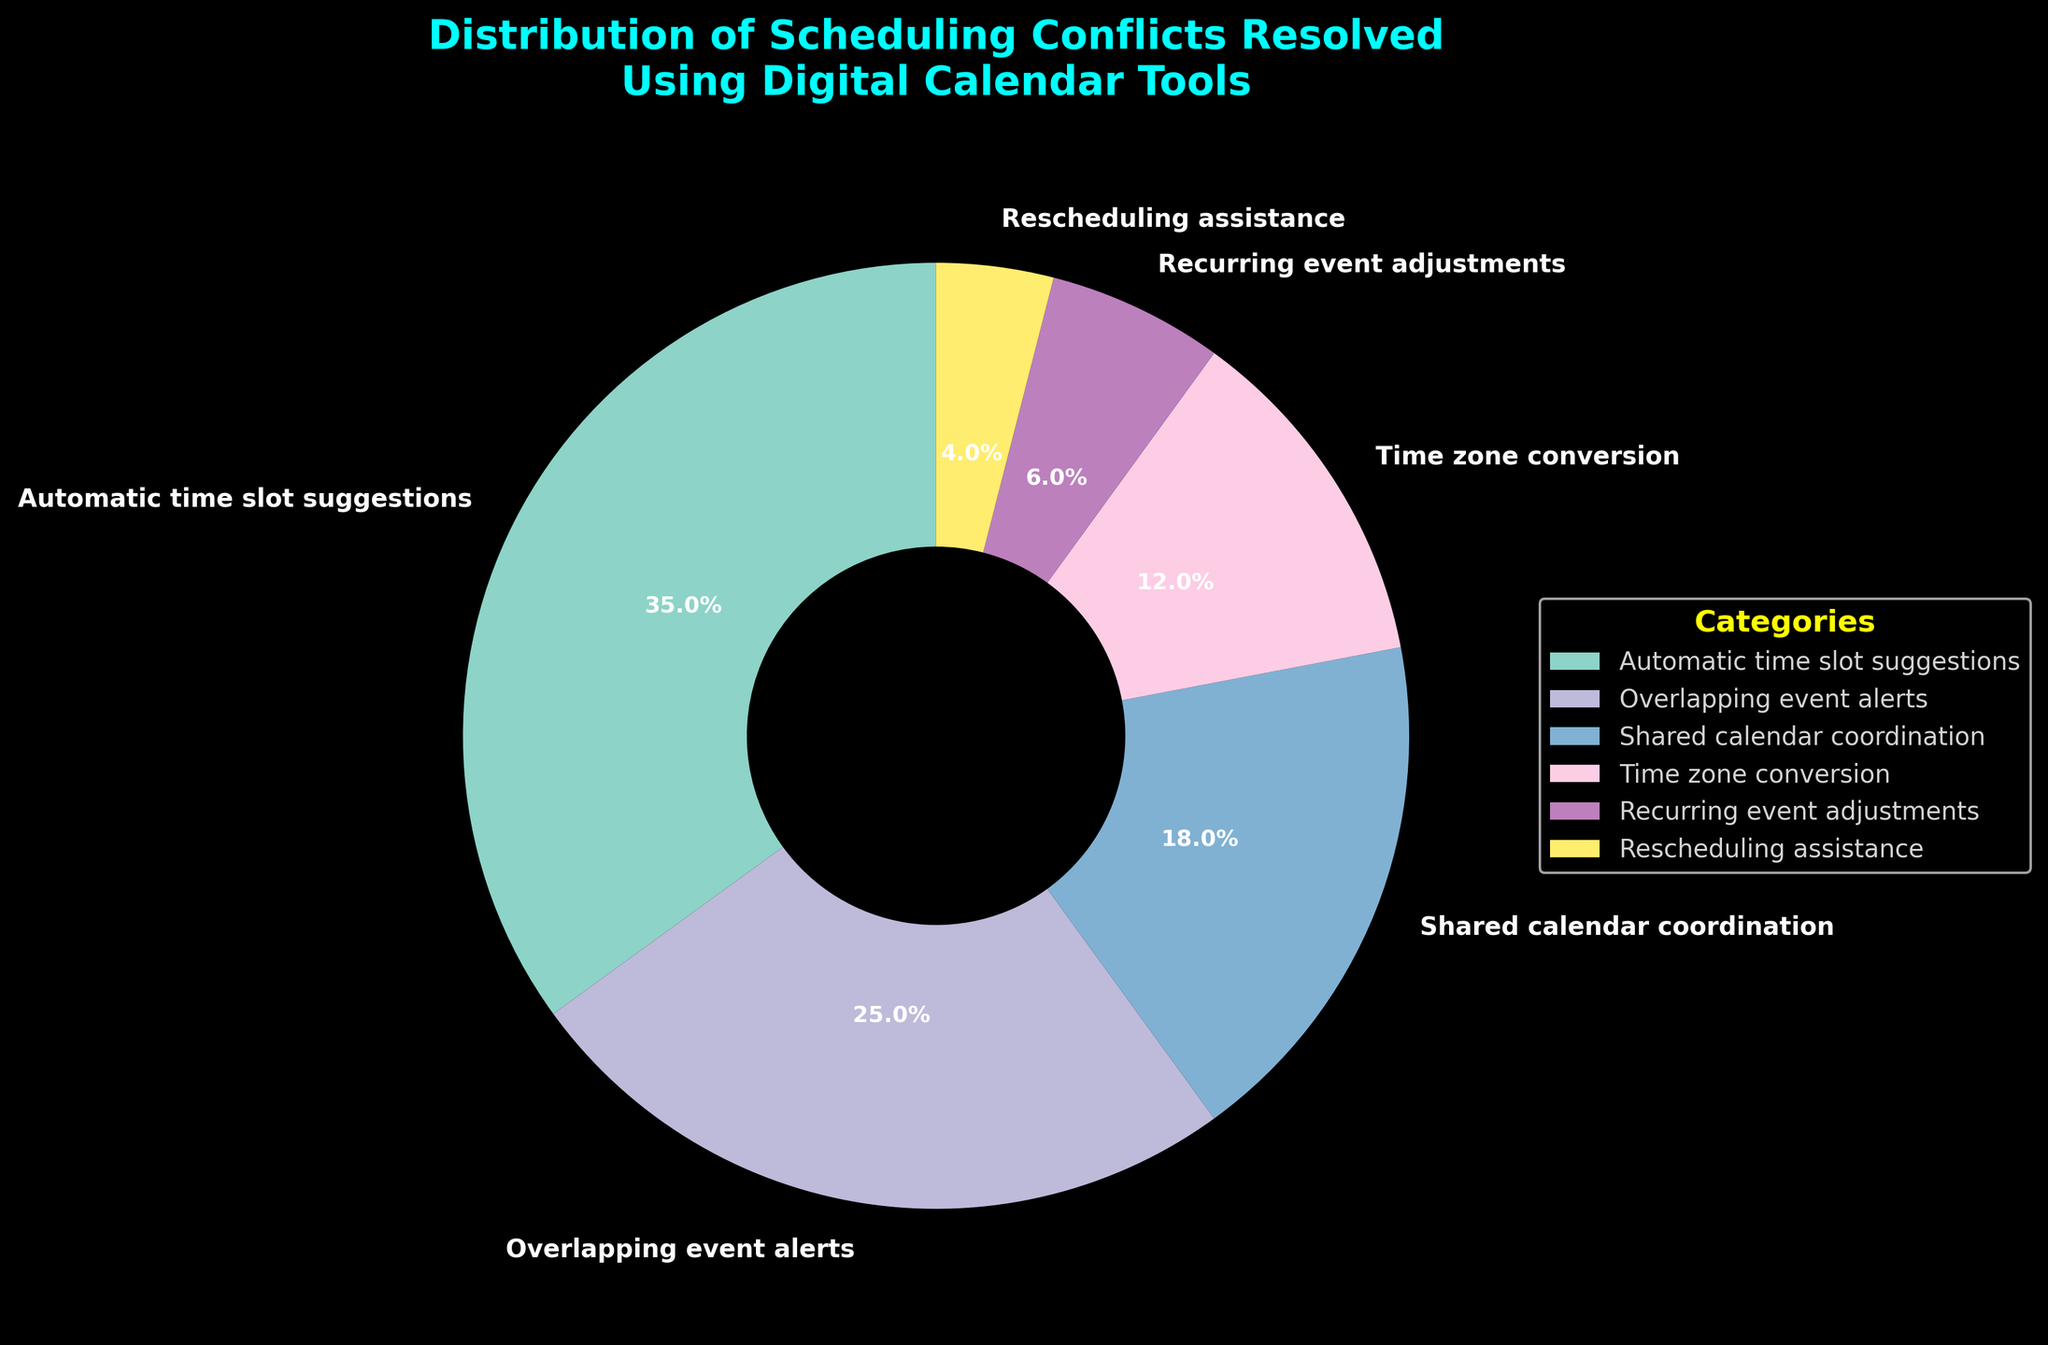What's the largest category for resolving scheduling conflicts? By examining the pie chart, it is clear that "Automatic time slot suggestions" takes up the largest portion of the chart.
Answer: Automatic time slot suggestions What's the sum of the percentages for "Automatic time slot suggestions" and "Overlapping event alerts"? Adding the percentages of "Automatic time slot suggestions" (35%) and "Overlapping event alerts" (25%) results in a total of 60%.
Answer: 60% Which category has a smaller percentage, "Recurring event adjustments" or "Rescheduling assistance"? The pie chart shows "Recurring event adjustments" at 6% and "Rescheduling assistance" at 4%. 4% is smaller than 6%.
Answer: Rescheduling assistance What is the difference between the percentage values of the largest and the smallest categories? The largest category, "Automatic time slot suggestions," is 35%, and the smallest category, "Rescheduling assistance," is 4%. The difference is 35% - 4% = 31%.
Answer: 31% Are the combined percentages of "Shared calendar coordination" and "Time zone conversion" greater or less than "Automatic time slot suggestions"? Adding the percentages of "Shared calendar coordination" (18%) and "Time zone conversion" (12%) results in 30%, which is less than 35% of "Automatic time slot suggestions".
Answer: Less What is the average percentage of the categories shown in the pie chart? Calculating the average involves summing up all percentages (35 + 25 + 18 + 12 + 6 + 4 = 100) and dividing by the number of categories (6), which gives an average of 100/6 ≈ 16.67%.
Answer: 16.67% Which is more significant for resolving scheduling conflicts: "Overlapping event alerts" or "Shared calendar coordination"? "Overlapping event alerts" has a higher percentage (25%) compared to "Shared calendar coordination" (18%) in the pie chart.
Answer: Overlapping event alerts What percentage is dedicated to "Recurring event adjustments" among the total categories combined? "Recurring event adjustments" has a percentage of 6%. Given the combined total percentage is 100%, "Recurring event adjustments" represents 6% of the total.
Answer: 6% Are "Time zone conversion" and "Recurring event adjustments" together making up more or less than 20% of the pie chart? Adding "Time zone conversion" (12%) and "Recurring event adjustments" (6%) results in 18%, which is less than 20%.
Answer: Less 